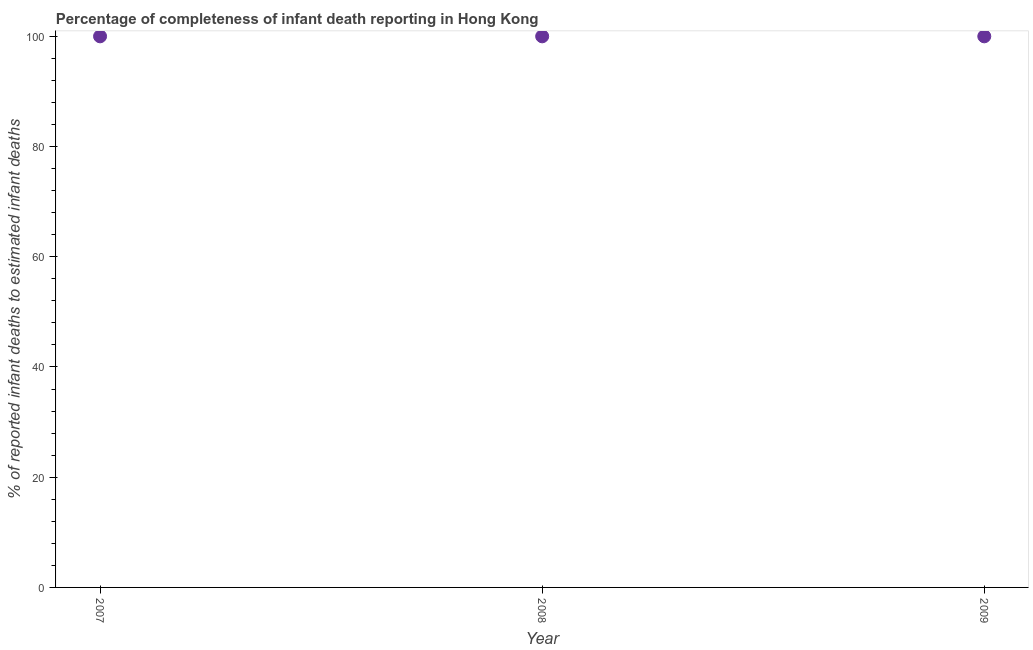What is the completeness of infant death reporting in 2007?
Offer a very short reply. 100. Across all years, what is the maximum completeness of infant death reporting?
Your response must be concise. 100. Across all years, what is the minimum completeness of infant death reporting?
Make the answer very short. 100. In which year was the completeness of infant death reporting maximum?
Provide a short and direct response. 2007. What is the sum of the completeness of infant death reporting?
Give a very brief answer. 300. What is the difference between the completeness of infant death reporting in 2008 and 2009?
Your answer should be compact. 0. What is the average completeness of infant death reporting per year?
Your answer should be very brief. 100. What is the median completeness of infant death reporting?
Provide a succinct answer. 100. Do a majority of the years between 2009 and 2008 (inclusive) have completeness of infant death reporting greater than 32 %?
Keep it short and to the point. No. Is the difference between the completeness of infant death reporting in 2007 and 2009 greater than the difference between any two years?
Make the answer very short. Yes. What is the difference between the highest and the second highest completeness of infant death reporting?
Provide a short and direct response. 0. Is the sum of the completeness of infant death reporting in 2007 and 2009 greater than the maximum completeness of infant death reporting across all years?
Offer a very short reply. Yes. In how many years, is the completeness of infant death reporting greater than the average completeness of infant death reporting taken over all years?
Provide a short and direct response. 0. How many years are there in the graph?
Provide a succinct answer. 3. What is the difference between two consecutive major ticks on the Y-axis?
Offer a terse response. 20. Does the graph contain any zero values?
Your response must be concise. No. Does the graph contain grids?
Make the answer very short. No. What is the title of the graph?
Your answer should be very brief. Percentage of completeness of infant death reporting in Hong Kong. What is the label or title of the Y-axis?
Offer a terse response. % of reported infant deaths to estimated infant deaths. What is the % of reported infant deaths to estimated infant deaths in 2007?
Give a very brief answer. 100. What is the % of reported infant deaths to estimated infant deaths in 2008?
Provide a short and direct response. 100. What is the % of reported infant deaths to estimated infant deaths in 2009?
Ensure brevity in your answer.  100. What is the difference between the % of reported infant deaths to estimated infant deaths in 2007 and 2009?
Give a very brief answer. 0. What is the difference between the % of reported infant deaths to estimated infant deaths in 2008 and 2009?
Your response must be concise. 0. What is the ratio of the % of reported infant deaths to estimated infant deaths in 2007 to that in 2009?
Your response must be concise. 1. 